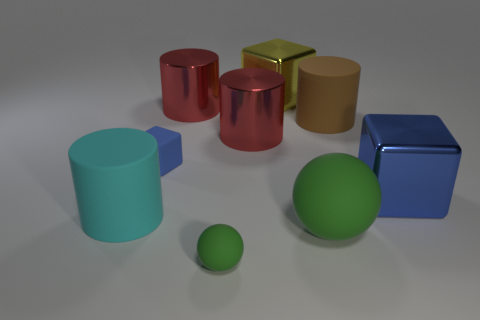Can you tell me which objects are similar in color and which ones diverge? Certainly! In the image, the blue metal cube and the smaller green sphere share cool color tones, though they are not the same color. On the other hand, the two cylinders—one red and one tan—exhibit warm colors but also vary in hue. The gold cube stands out with its unique metallic sheen. 